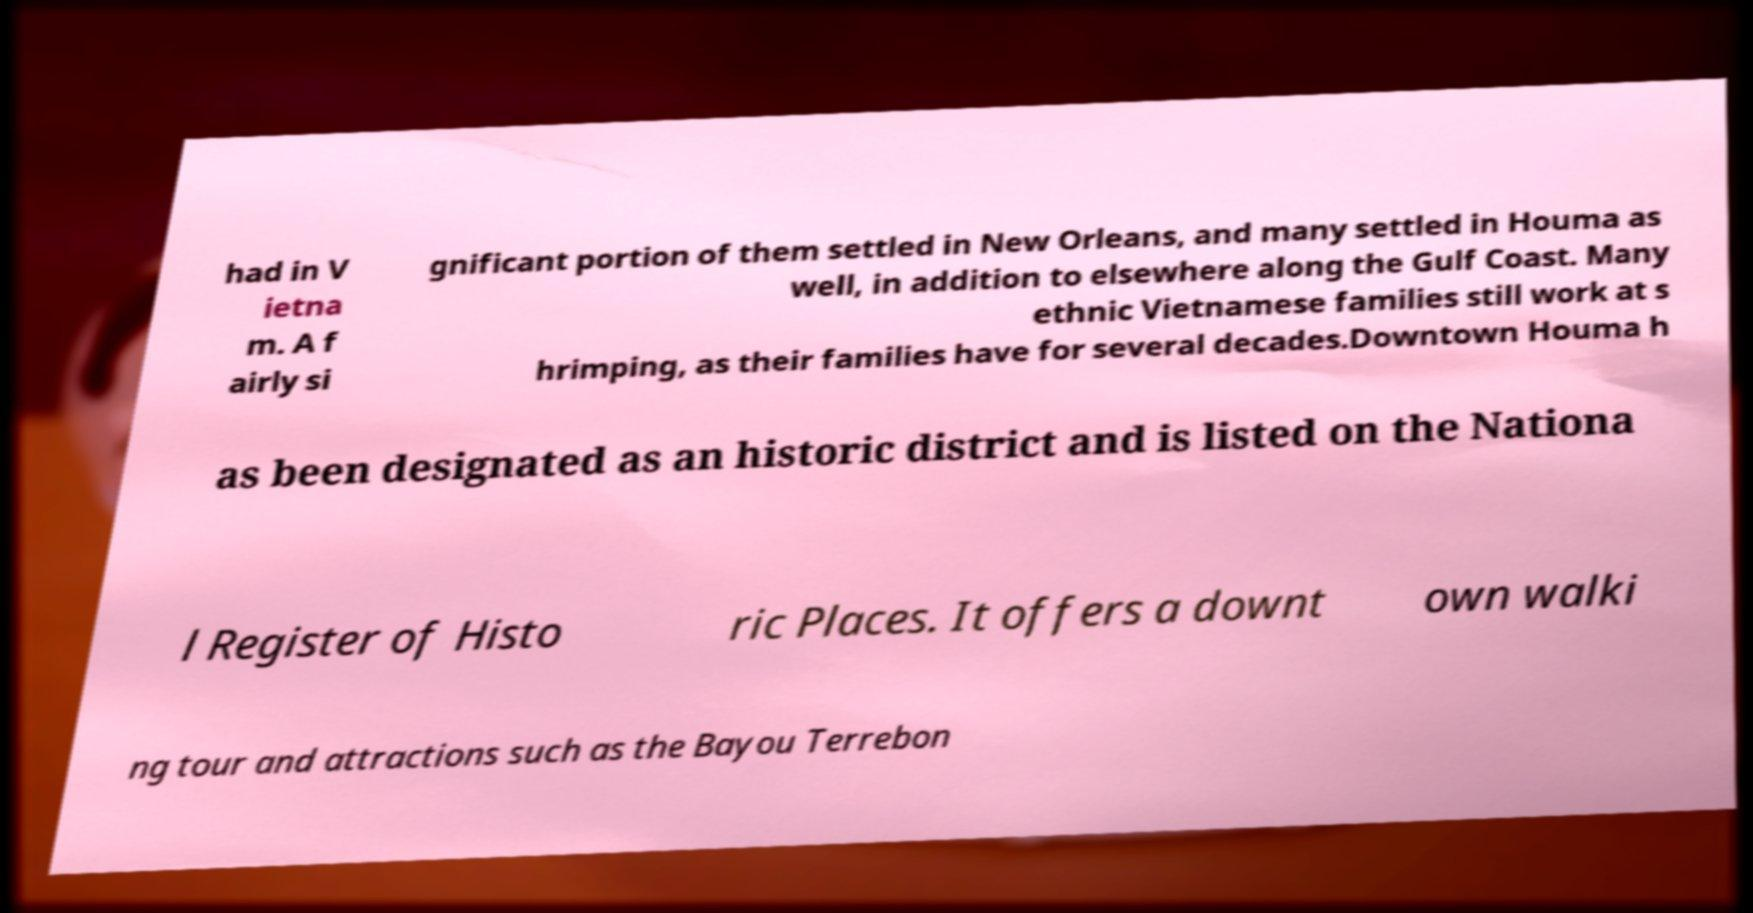Could you assist in decoding the text presented in this image and type it out clearly? had in V ietna m. A f airly si gnificant portion of them settled in New Orleans, and many settled in Houma as well, in addition to elsewhere along the Gulf Coast. Many ethnic Vietnamese families still work at s hrimping, as their families have for several decades.Downtown Houma h as been designated as an historic district and is listed on the Nationa l Register of Histo ric Places. It offers a downt own walki ng tour and attractions such as the Bayou Terrebon 